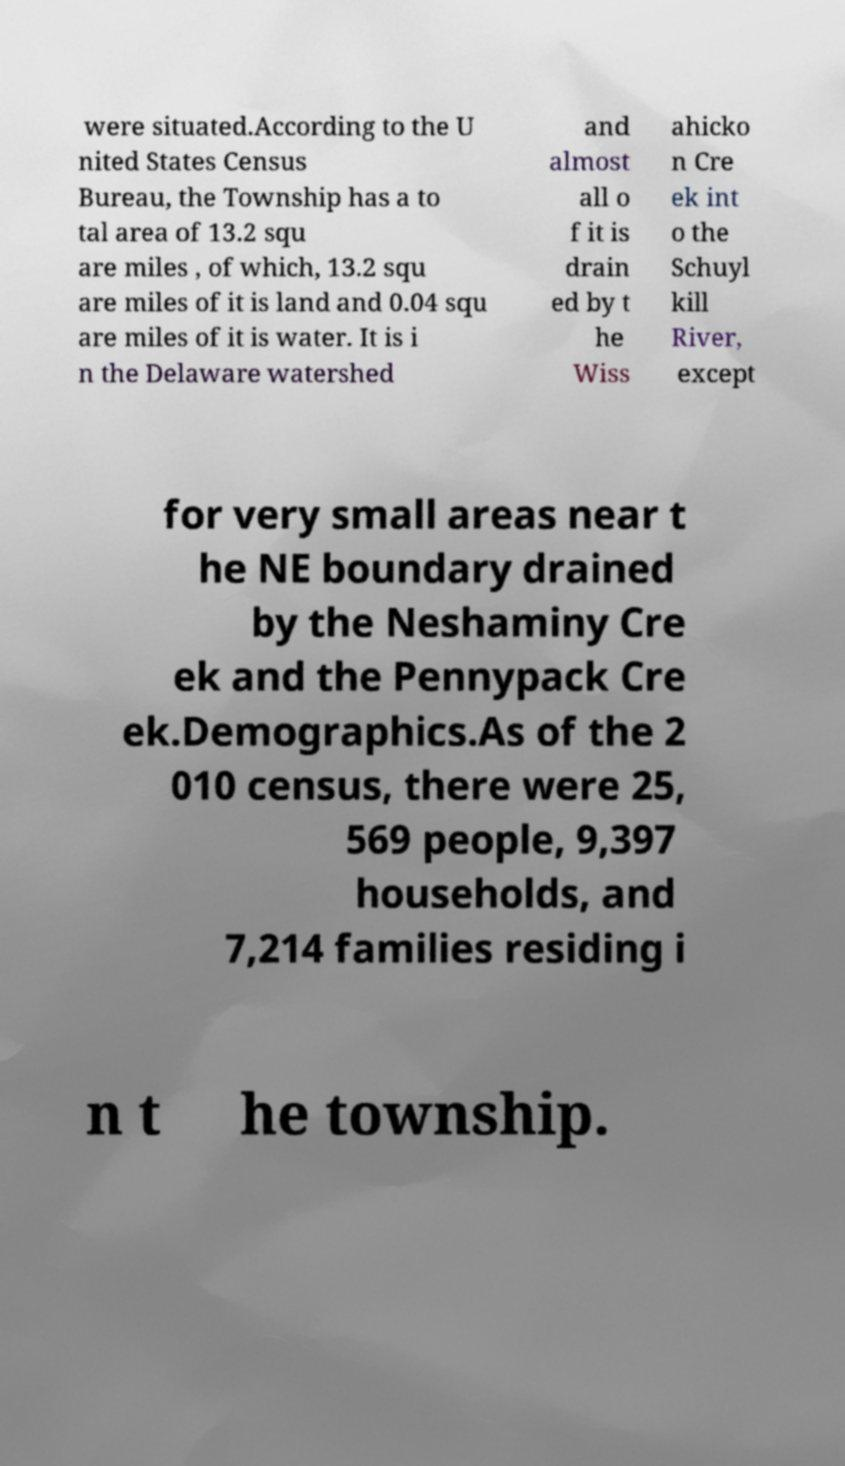Could you assist in decoding the text presented in this image and type it out clearly? were situated.According to the U nited States Census Bureau, the Township has a to tal area of 13.2 squ are miles , of which, 13.2 squ are miles of it is land and 0.04 squ are miles of it is water. It is i n the Delaware watershed and almost all o f it is drain ed by t he Wiss ahicko n Cre ek int o the Schuyl kill River, except for very small areas near t he NE boundary drained by the Neshaminy Cre ek and the Pennypack Cre ek.Demographics.As of the 2 010 census, there were 25, 569 people, 9,397 households, and 7,214 families residing i n t he township. 